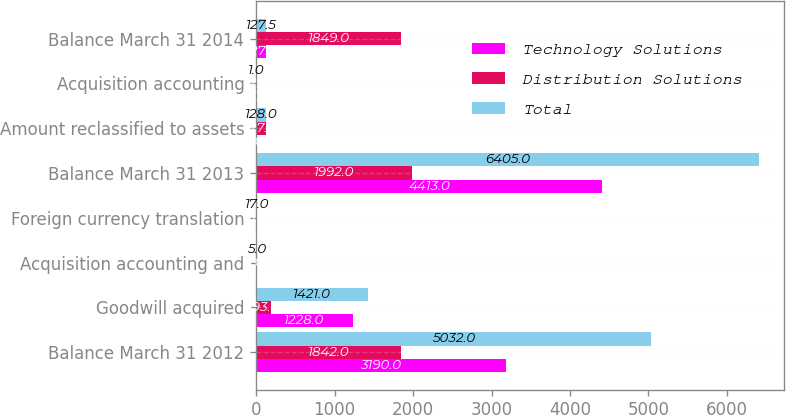Convert chart. <chart><loc_0><loc_0><loc_500><loc_500><stacked_bar_chart><ecel><fcel>Balance March 31 2012<fcel>Goodwill acquired<fcel>Acquisition accounting and<fcel>Foreign currency translation<fcel>Balance March 31 2013<fcel>Amount reclassified to assets<fcel>Acquisition accounting<fcel>Balance March 31 2014<nl><fcel>Technology Solutions<fcel>3190<fcel>1228<fcel>6<fcel>11<fcel>4413<fcel>1<fcel>13<fcel>127.5<nl><fcel>Distribution Solutions<fcel>1842<fcel>193<fcel>1<fcel>6<fcel>1992<fcel>127<fcel>12<fcel>1849<nl><fcel>Total<fcel>5032<fcel>1421<fcel>5<fcel>17<fcel>6405<fcel>128<fcel>1<fcel>127.5<nl></chart> 